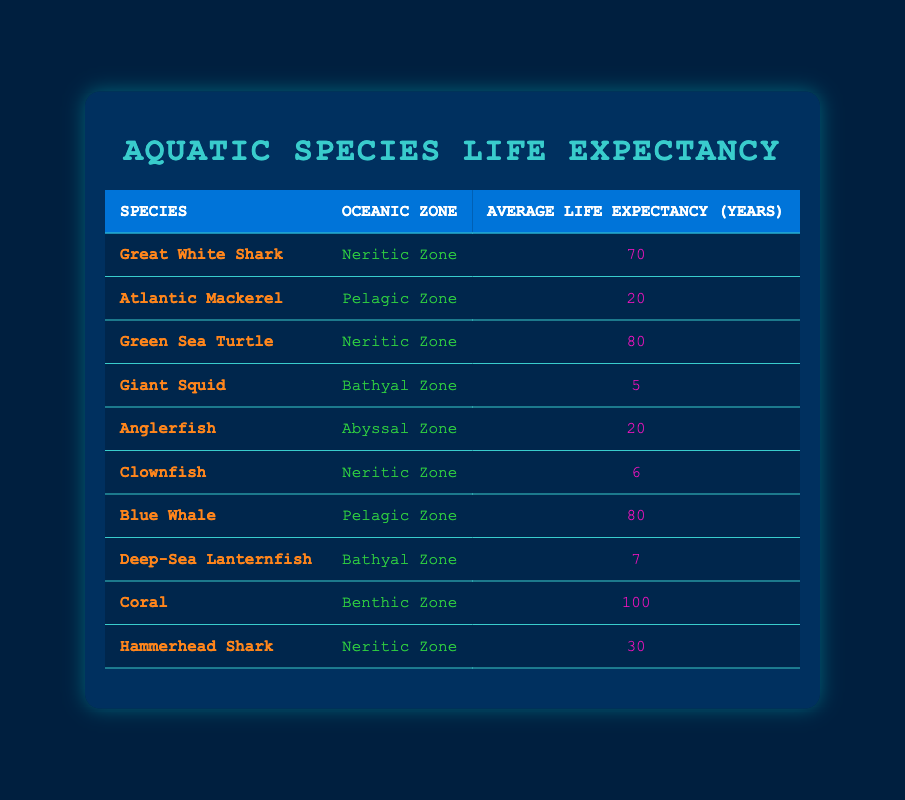What is the average life expectancy of the species found in the Neritic Zone? There are four species in the Neritic Zone: Great White Shark (70 years), Green Sea Turtle (80 years), Clownfish (6 years), and Hammerhead Shark (30 years). To find the average, add their life expectancies: 70 + 80 + 6 + 30 = 186. Then, divide by the number of species: 186 / 4 = 46.5 years.
Answer: 46.5 years Which aquatic species has the longest life expectancy? The species with the longest life expectancy is Coral, which has an average life expectancy of 100 years. This can be directly observed in the table where Coral is listed with its average life expectancy.
Answer: Coral Is the average life expectancy of species in the Pelagic Zone greater than those in the Bathyal Zone? In the Pelagic Zone, the average life expectancy is calculated using Atlantic Mackerel (20 years) and Blue Whale (80 years), which totals 100 years and then divides by 2 to get 50 years. In the Bathyal Zone, with Giant Squid (5 years) and Deep-Sea Lanternfish (7 years), the total is 12 years, and dividing by 2 results in 6 years. Since 50 > 6, the average life expectancy in the Pelagic Zone is greater.
Answer: Yes How many species have a life expectancy of less than 10 years? There are two species with a life expectancy of less than 10 years: Giant Squid (5 years) and Clownfish (6 years). This can be found by checking each species' life expectancy in the table and counting those under 10 years.
Answer: 2 How would you summarize the species life expectancy by oceanic zone? In the Neritic Zone, the average is 46.5 years; in the Pelagic Zone, it is 50 years; Bathyal Zone has an average of 6 years; in the Abyssal Zone, it is 20 years; and for the Benthic Zone, it is 100 years. Summarizing requires collecting average values for all species listed in each oceanic zone as seen in the data.
Answer: 46.5 years (Neritic), 50 years (Pelagic), 6 years (Bathyal), 20 years (Abyssal), 100 years (Benthic) 